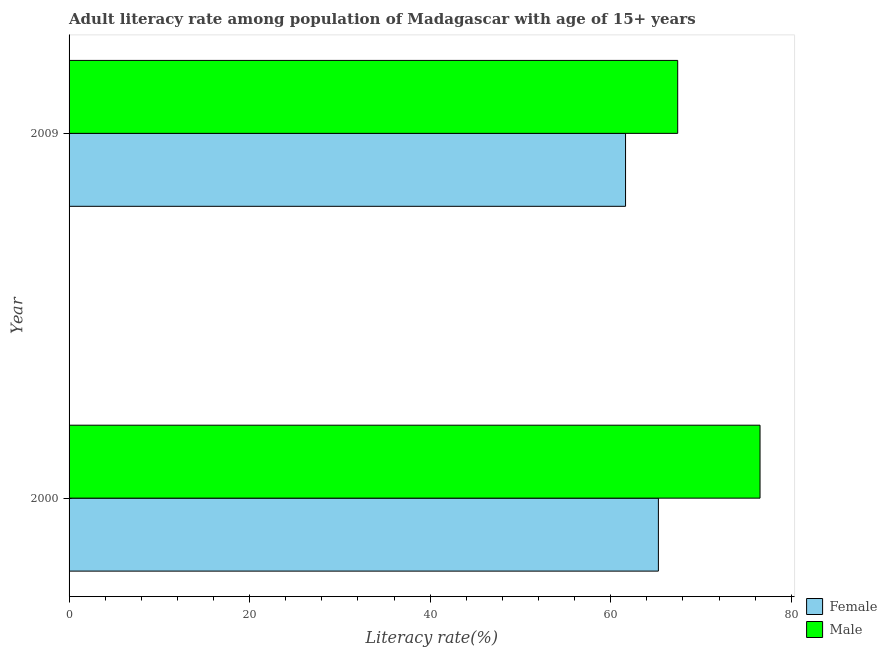How many different coloured bars are there?
Your answer should be compact. 2. How many groups of bars are there?
Your answer should be very brief. 2. Are the number of bars per tick equal to the number of legend labels?
Make the answer very short. Yes. How many bars are there on the 1st tick from the top?
Offer a very short reply. 2. In how many cases, is the number of bars for a given year not equal to the number of legend labels?
Your answer should be very brief. 0. What is the male adult literacy rate in 2009?
Provide a short and direct response. 67.42. Across all years, what is the maximum female adult literacy rate?
Offer a very short reply. 65.28. Across all years, what is the minimum female adult literacy rate?
Offer a very short reply. 61.64. What is the total male adult literacy rate in the graph?
Provide a short and direct response. 143.96. What is the difference between the male adult literacy rate in 2000 and that in 2009?
Give a very brief answer. 9.12. What is the difference between the male adult literacy rate in 2000 and the female adult literacy rate in 2009?
Provide a succinct answer. 14.9. What is the average male adult literacy rate per year?
Provide a short and direct response. 71.98. In the year 2000, what is the difference between the male adult literacy rate and female adult literacy rate?
Make the answer very short. 11.26. In how many years, is the female adult literacy rate greater than 60 %?
Give a very brief answer. 2. What is the ratio of the female adult literacy rate in 2000 to that in 2009?
Give a very brief answer. 1.06. In how many years, is the female adult literacy rate greater than the average female adult literacy rate taken over all years?
Your response must be concise. 1. What does the 2nd bar from the bottom in 2000 represents?
Give a very brief answer. Male. How many bars are there?
Offer a terse response. 4. Are all the bars in the graph horizontal?
Your response must be concise. Yes. What is the difference between two consecutive major ticks on the X-axis?
Provide a short and direct response. 20. Does the graph contain any zero values?
Ensure brevity in your answer.  No. Does the graph contain grids?
Your answer should be compact. No. Where does the legend appear in the graph?
Provide a succinct answer. Bottom right. How many legend labels are there?
Provide a succinct answer. 2. How are the legend labels stacked?
Your answer should be very brief. Vertical. What is the title of the graph?
Give a very brief answer. Adult literacy rate among population of Madagascar with age of 15+ years. Does "Under-5(female)" appear as one of the legend labels in the graph?
Your answer should be very brief. No. What is the label or title of the X-axis?
Offer a very short reply. Literacy rate(%). What is the label or title of the Y-axis?
Your response must be concise. Year. What is the Literacy rate(%) in Female in 2000?
Make the answer very short. 65.28. What is the Literacy rate(%) in Male in 2000?
Make the answer very short. 76.54. What is the Literacy rate(%) of Female in 2009?
Your answer should be very brief. 61.64. What is the Literacy rate(%) in Male in 2009?
Give a very brief answer. 67.42. Across all years, what is the maximum Literacy rate(%) in Female?
Provide a short and direct response. 65.28. Across all years, what is the maximum Literacy rate(%) of Male?
Ensure brevity in your answer.  76.54. Across all years, what is the minimum Literacy rate(%) of Female?
Ensure brevity in your answer.  61.64. Across all years, what is the minimum Literacy rate(%) in Male?
Provide a short and direct response. 67.42. What is the total Literacy rate(%) in Female in the graph?
Make the answer very short. 126.92. What is the total Literacy rate(%) in Male in the graph?
Offer a terse response. 143.96. What is the difference between the Literacy rate(%) of Female in 2000 and that in 2009?
Your response must be concise. 3.64. What is the difference between the Literacy rate(%) of Male in 2000 and that in 2009?
Offer a very short reply. 9.12. What is the difference between the Literacy rate(%) of Female in 2000 and the Literacy rate(%) of Male in 2009?
Provide a succinct answer. -2.14. What is the average Literacy rate(%) of Female per year?
Your answer should be very brief. 63.46. What is the average Literacy rate(%) in Male per year?
Your response must be concise. 71.98. In the year 2000, what is the difference between the Literacy rate(%) of Female and Literacy rate(%) of Male?
Keep it short and to the point. -11.26. In the year 2009, what is the difference between the Literacy rate(%) in Female and Literacy rate(%) in Male?
Ensure brevity in your answer.  -5.78. What is the ratio of the Literacy rate(%) in Female in 2000 to that in 2009?
Offer a terse response. 1.06. What is the ratio of the Literacy rate(%) of Male in 2000 to that in 2009?
Give a very brief answer. 1.14. What is the difference between the highest and the second highest Literacy rate(%) in Female?
Ensure brevity in your answer.  3.64. What is the difference between the highest and the second highest Literacy rate(%) of Male?
Ensure brevity in your answer.  9.12. What is the difference between the highest and the lowest Literacy rate(%) of Female?
Provide a short and direct response. 3.64. What is the difference between the highest and the lowest Literacy rate(%) in Male?
Offer a very short reply. 9.12. 